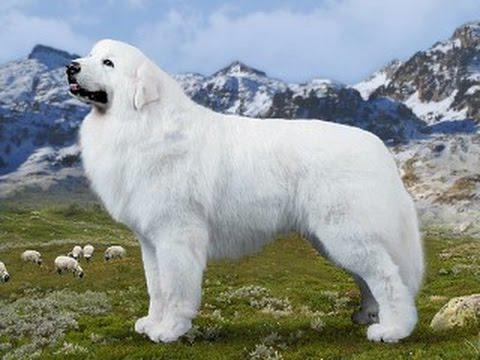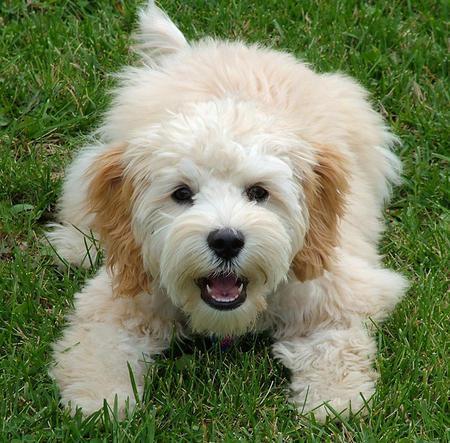The first image is the image on the left, the second image is the image on the right. For the images shown, is this caption "One of the dogs is sitting with its legs extended on the ground." true? Answer yes or no. Yes. 